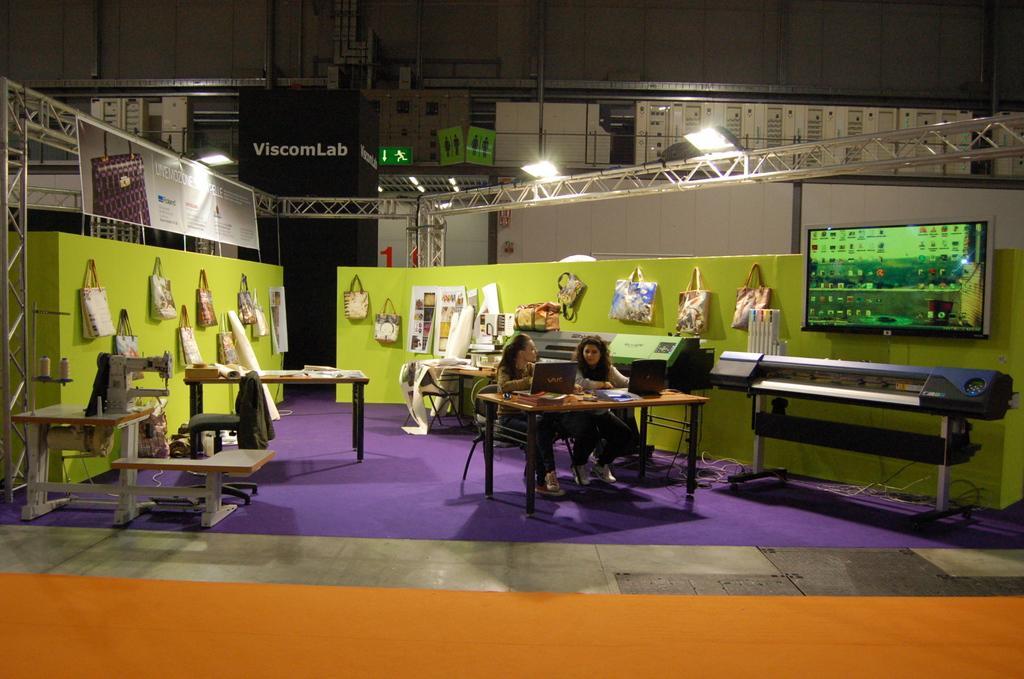Describe this image in one or two sentences. In this image i can see two women sitting on a chair and doing work on the laptop, in front there is a table, at the back ground i can see, bench, a table and few bags hanging to a wall, a building, and a pole. 